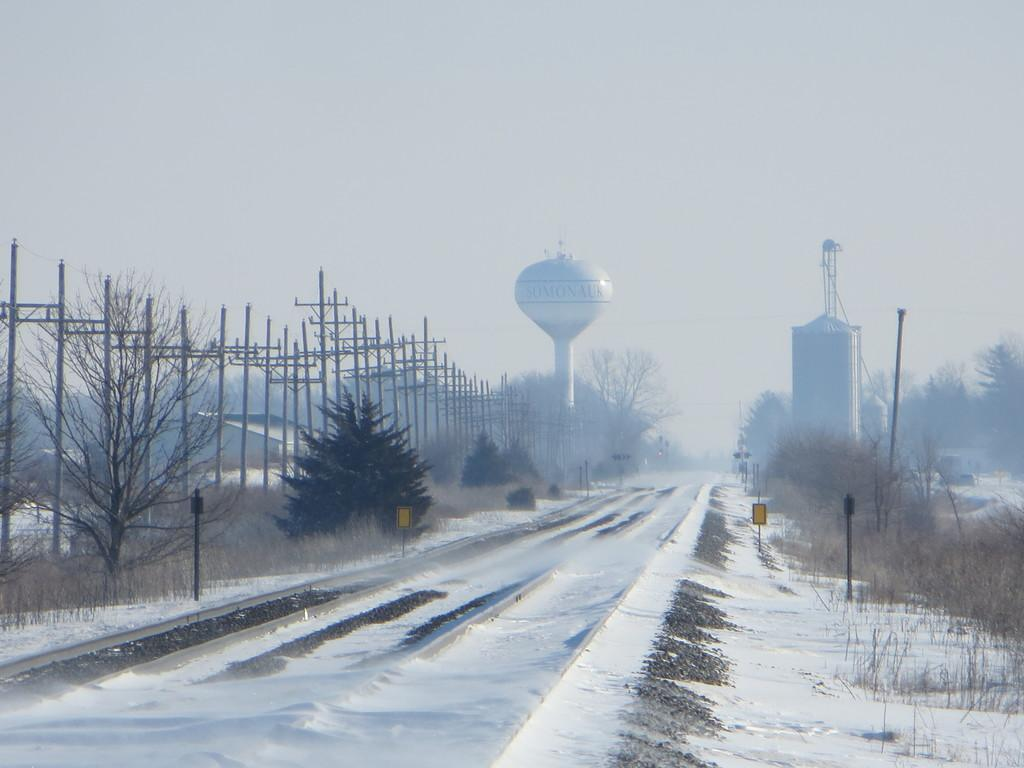What is the condition of the ground in the image? The ground in the image is covered with snow. What type of natural elements can be seen in the image? There are trees in the image. What type of man-made structures are present in the image? There are buildings in the image. How many times did the person kick the snow in the image? There is no person present in the image, and therefore no one is kicking the snow. 